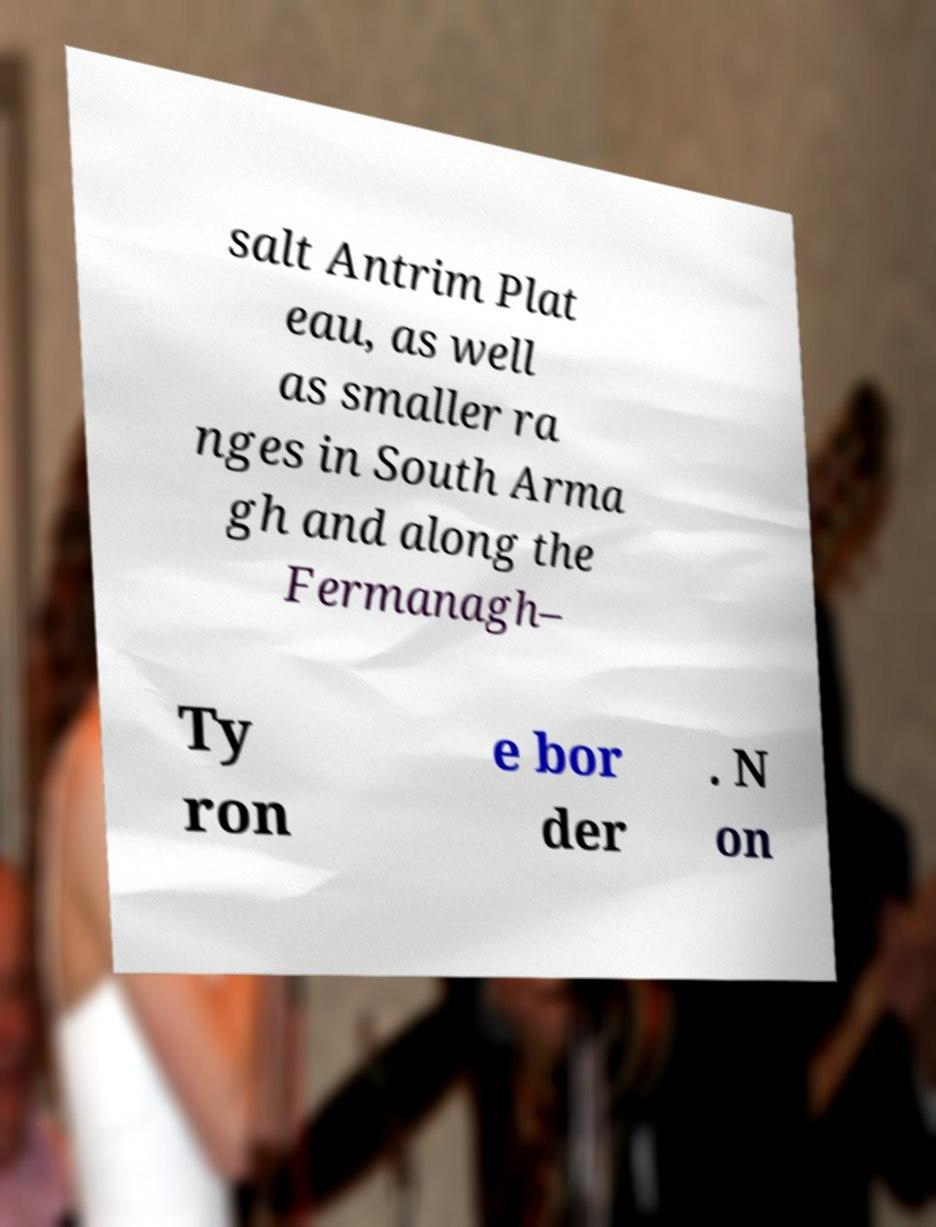Could you assist in decoding the text presented in this image and type it out clearly? salt Antrim Plat eau, as well as smaller ra nges in South Arma gh and along the Fermanagh– Ty ron e bor der . N on 